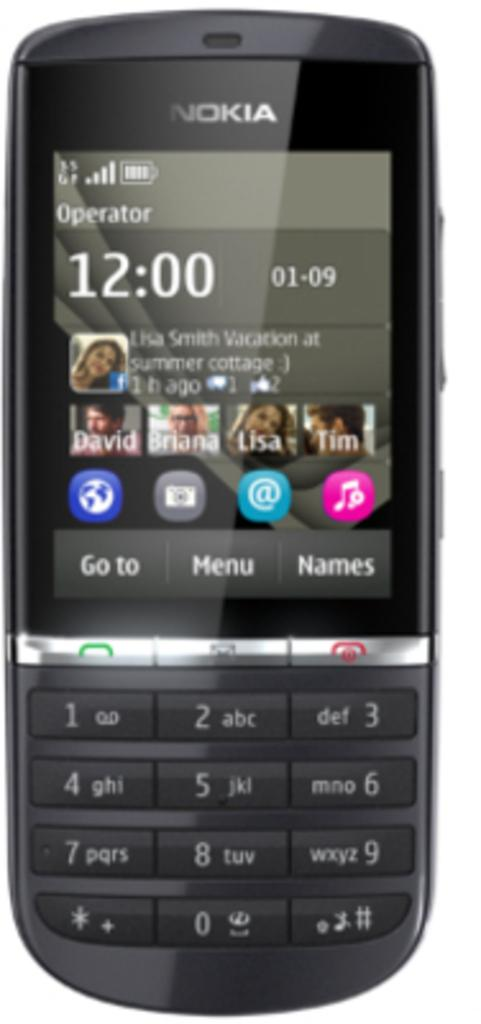<image>
Create a compact narrative representing the image presented. A Nokia phone with the time of 12:00 on 01-09 